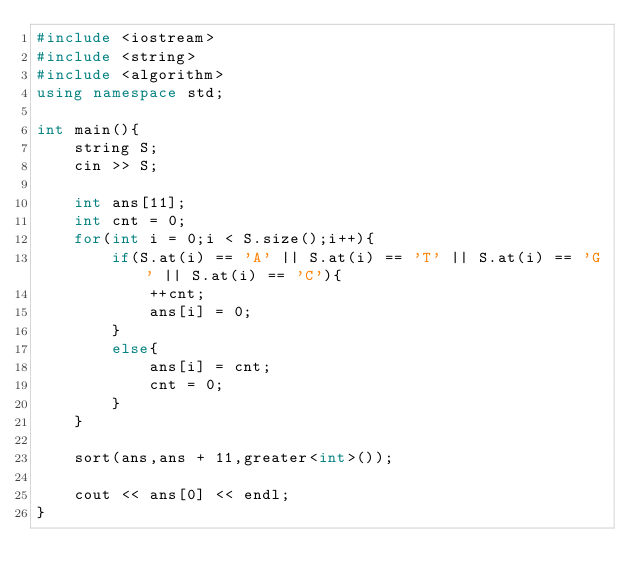Convert code to text. <code><loc_0><loc_0><loc_500><loc_500><_C++_>#include <iostream>
#include <string>
#include <algorithm>
using namespace std;

int main(){
    string S;
    cin >> S;
    
    int ans[11];
    int cnt = 0;
    for(int i = 0;i < S.size();i++){
        if(S.at(i) == 'A' || S.at(i) == 'T' || S.at(i) == 'G' || S.at(i) == 'C'){
            ++cnt;
            ans[i] = 0;
        }
        else{
            ans[i] = cnt;
            cnt = 0;
        }
    }
    
    sort(ans,ans + 11,greater<int>());
    
    cout << ans[0] << endl;
}

</code> 